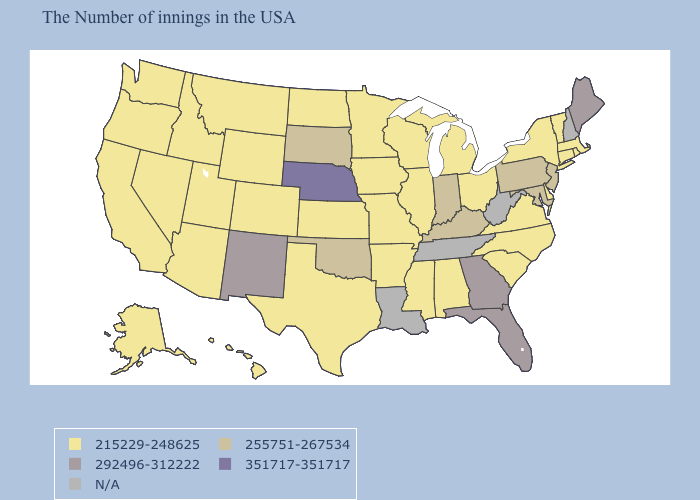What is the value of Wyoming?
Quick response, please. 215229-248625. Name the states that have a value in the range N/A?
Answer briefly. New Hampshire, West Virginia, Tennessee, Louisiana. Which states hav the highest value in the MidWest?
Quick response, please. Nebraska. What is the value of Georgia?
Concise answer only. 292496-312222. Does New Jersey have the lowest value in the Northeast?
Be succinct. No. What is the value of Hawaii?
Short answer required. 215229-248625. Name the states that have a value in the range 255751-267534?
Concise answer only. New Jersey, Maryland, Pennsylvania, Kentucky, Indiana, Oklahoma, South Dakota. How many symbols are there in the legend?
Keep it brief. 5. How many symbols are there in the legend?
Concise answer only. 5. Name the states that have a value in the range 255751-267534?
Concise answer only. New Jersey, Maryland, Pennsylvania, Kentucky, Indiana, Oklahoma, South Dakota. Does the map have missing data?
Write a very short answer. Yes. What is the highest value in states that border Massachusetts?
Concise answer only. 215229-248625. Name the states that have a value in the range 292496-312222?
Keep it brief. Maine, Florida, Georgia, New Mexico. What is the value of Louisiana?
Write a very short answer. N/A. 